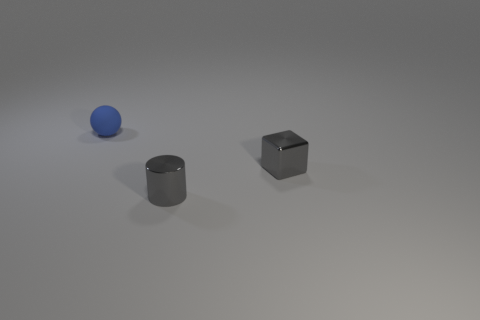Is the color of the metallic block the same as the tiny rubber object?
Your answer should be compact. No. Is the material of the gray cube behind the tiny cylinder the same as the small ball that is to the left of the metallic cylinder?
Ensure brevity in your answer.  No. How many objects are either big purple rubber objects or objects that are to the right of the blue thing?
Your answer should be compact. 2. Is there anything else that is the same material as the sphere?
Provide a succinct answer. No. What is the shape of the metallic thing that is the same color as the small cylinder?
Give a very brief answer. Cube. What is the material of the tiny gray block?
Offer a very short reply. Metal. Is the blue sphere made of the same material as the small cube?
Give a very brief answer. No. What number of shiny objects are gray cubes or small balls?
Make the answer very short. 1. There is a tiny metallic thing that is behind the small cylinder; what shape is it?
Your response must be concise. Cube. There is a gray cube that is made of the same material as the gray cylinder; what size is it?
Offer a terse response. Small. 